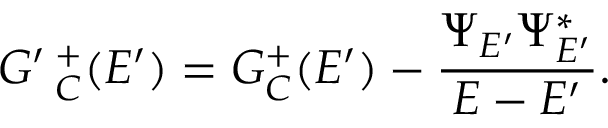Convert formula to latex. <formula><loc_0><loc_0><loc_500><loc_500>G ^ { \prime } \, _ { C } ^ { + } ( E ^ { \prime } ) = G _ { C } ^ { + } ( E ^ { \prime } ) - \frac { \Psi _ { E ^ { \prime } } \Psi _ { E ^ { \prime } } ^ { * } } { E - E ^ { \prime } } .</formula> 